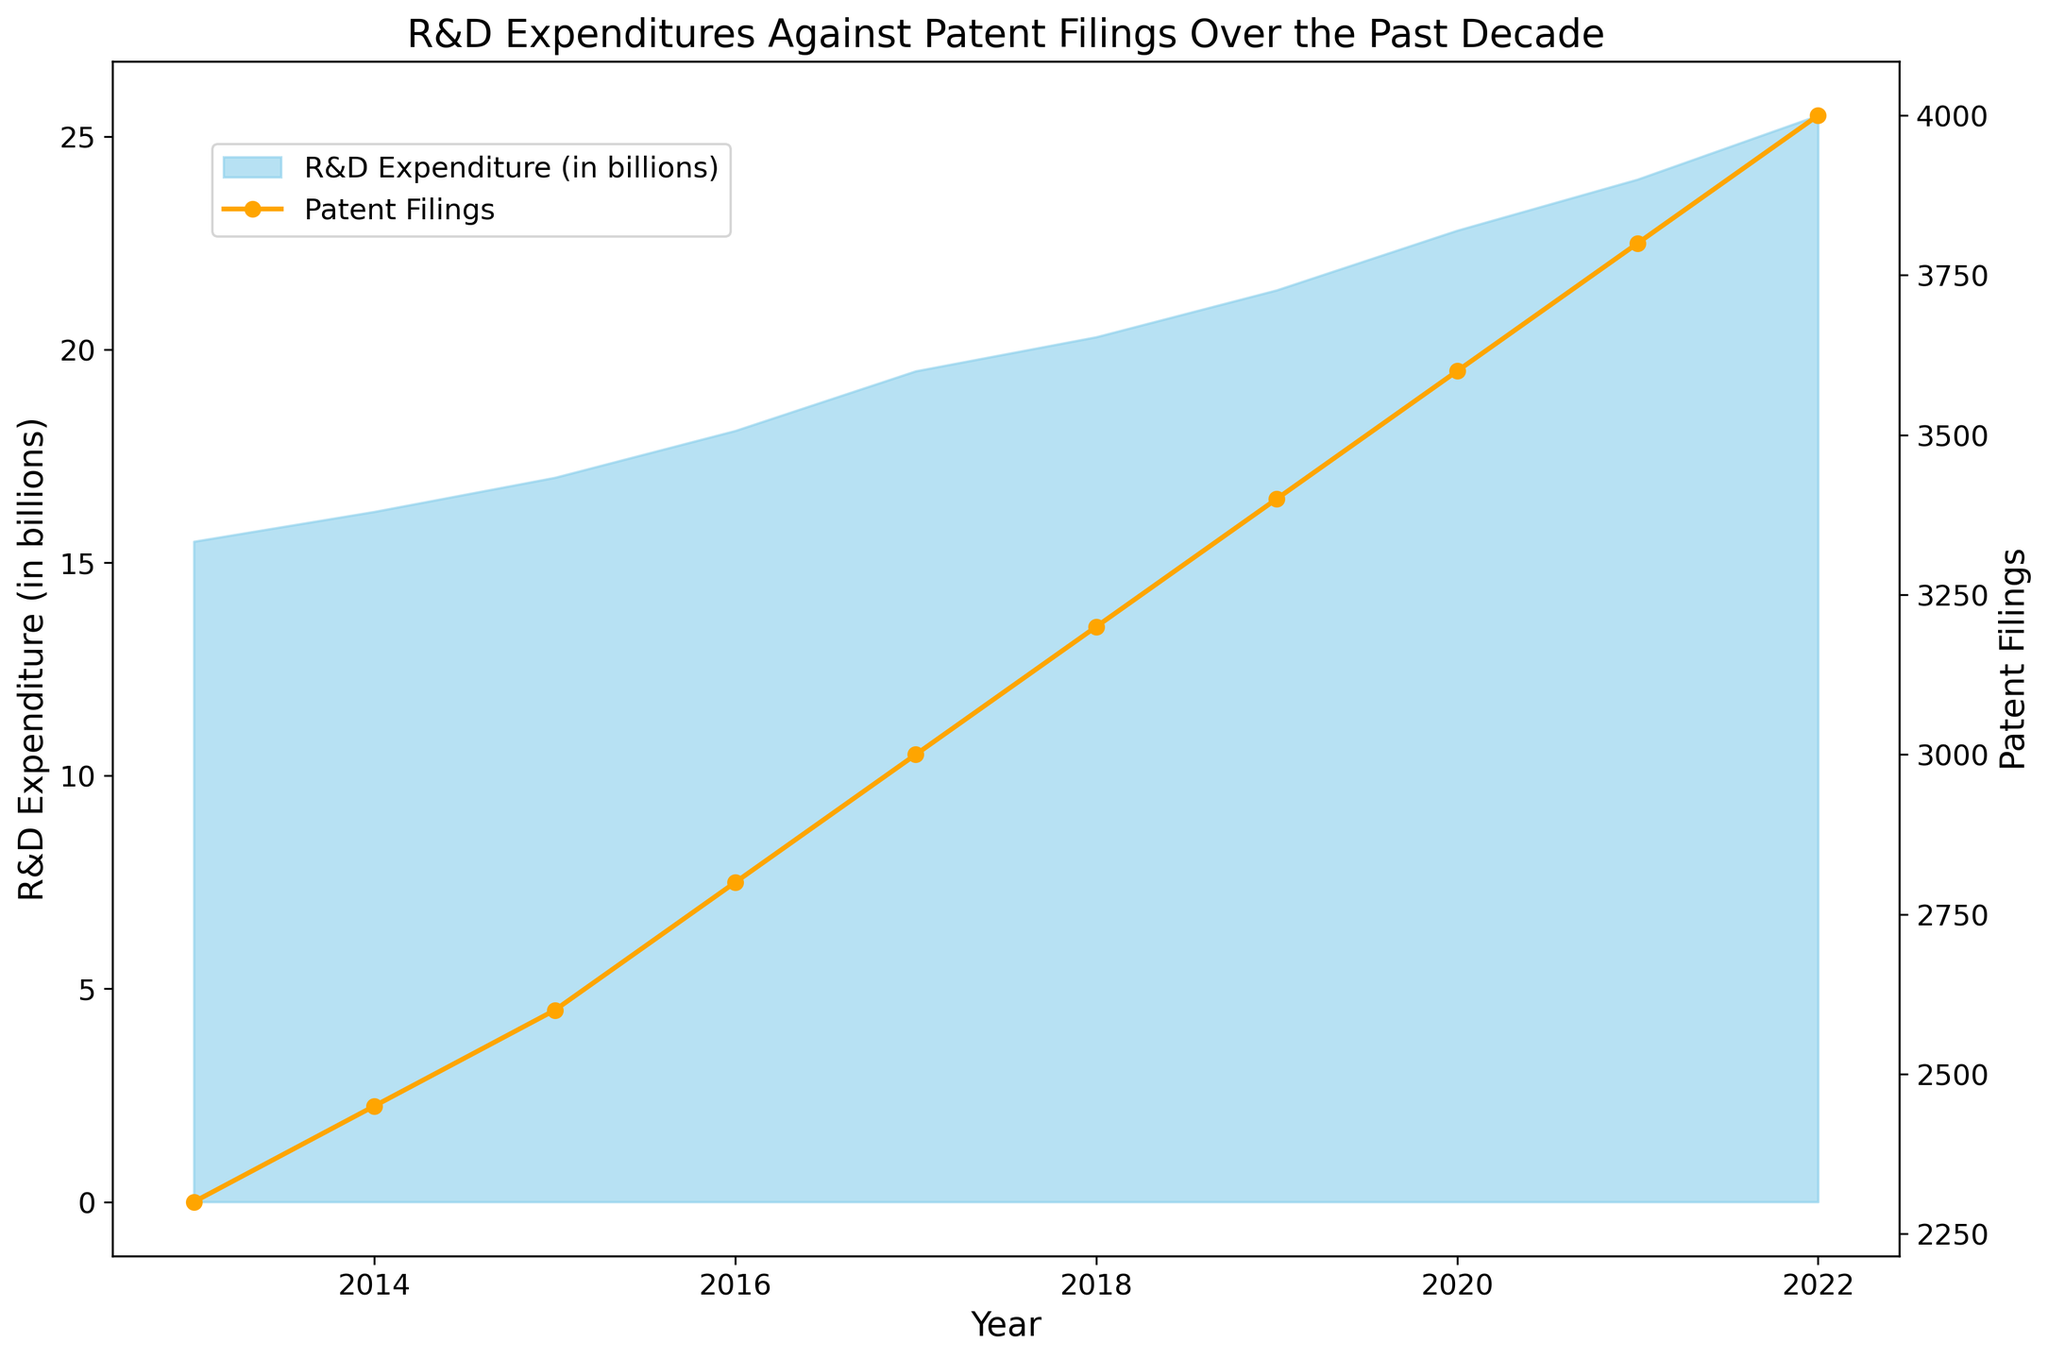What's the trend in R&D expenditures from 2013 to 2022? From the figure, the R&D expenditures show a clear increasing trend year-by-year from 15.5 billion in 2013 to 25.5 billion in 2022.
Answer: Increasing Which year experienced the greatest increase in R&D expenditures compared to the previous year? The largest year-over-year increase in R&D expenditures can be observed between 2021 (24.0 billion) and 2022 (25.5 billion), where it increased by 1.5 billion.
Answer: 2022 In what year did patent filings reach 3000? According to the figure, patent filings reached 3000 in the year 2017.
Answer: 2017 How does the trend in patent filings compare to the trend in R&D expenditures over the same period? Both R&D expenditures and patent filings exhibit an increasing trend from 2013 to 2022, indicating a positive correlation where higher R&D expenditures are associated with more patent filings.
Answer: Both are increasing What is the difference in R&D expenditures between 2013 and 2022? The R&D expenditures in 2013 were 15.5 billion, whereas in 2022, they were 25.5 billion. The difference is 25.5 billion - 15.5 billion = 10 billion.
Answer: 10 billion Calculate the average annual R&D expenditure over the decade. The sum of the R&D expenditures from 2013 to 2022 is 15.5 + 16.2 + 17.0 + 18.1 + 19.5 + 20.3 + 21.4 + 22.8 + 24.0 + 25.5 = 200.3 billion. The average is 200.3 billion / 10 years = 20.03 billion per year.
Answer: 20.03 billion In which year did the patent filings first exceed 3500? As indicated in the figure, patent filings first exceeded 3500 in the year 2020.
Answer: 2020 What is the visual representation used for R&D expenditures and patent filings in the figure? The R&D expenditures are represented using a filled area (in sky blue color), while the patent filings are represented using a line with markers (in orange color).
Answer: Filled area for R&D and line for patents Which metric (R&D expenditures or patent filings) appears to have more variability over the years? By observing the trends in the figure, R&D expenditures appear to have a more gradual and steady increase, whereas patent filings show similarly steady growth but with slight increases in variability as indicated by the line markers.
Answer: Patent filings What is the ratio of patent filings to R&D expenditures in 2021? In 2021, there were 3800 patent filings and R&D expenditures were 24.0 billion. The ratio is 3800 / 24.0 = 158.33.
Answer: 158.33 